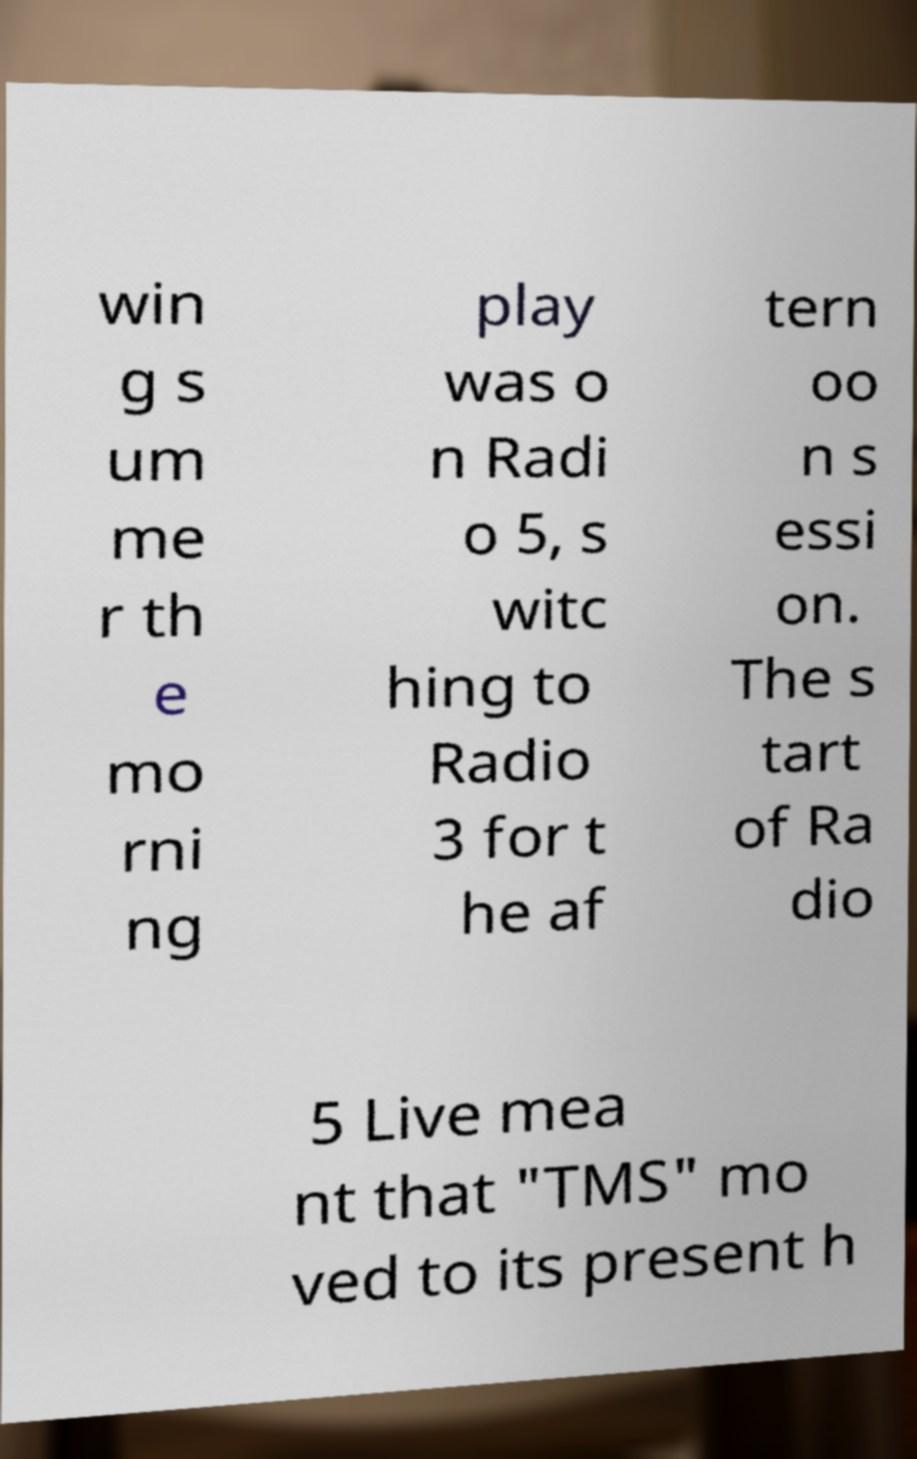Can you read and provide the text displayed in the image?This photo seems to have some interesting text. Can you extract and type it out for me? win g s um me r th e mo rni ng play was o n Radi o 5, s witc hing to Radio 3 for t he af tern oo n s essi on. The s tart of Ra dio 5 Live mea nt that "TMS" mo ved to its present h 